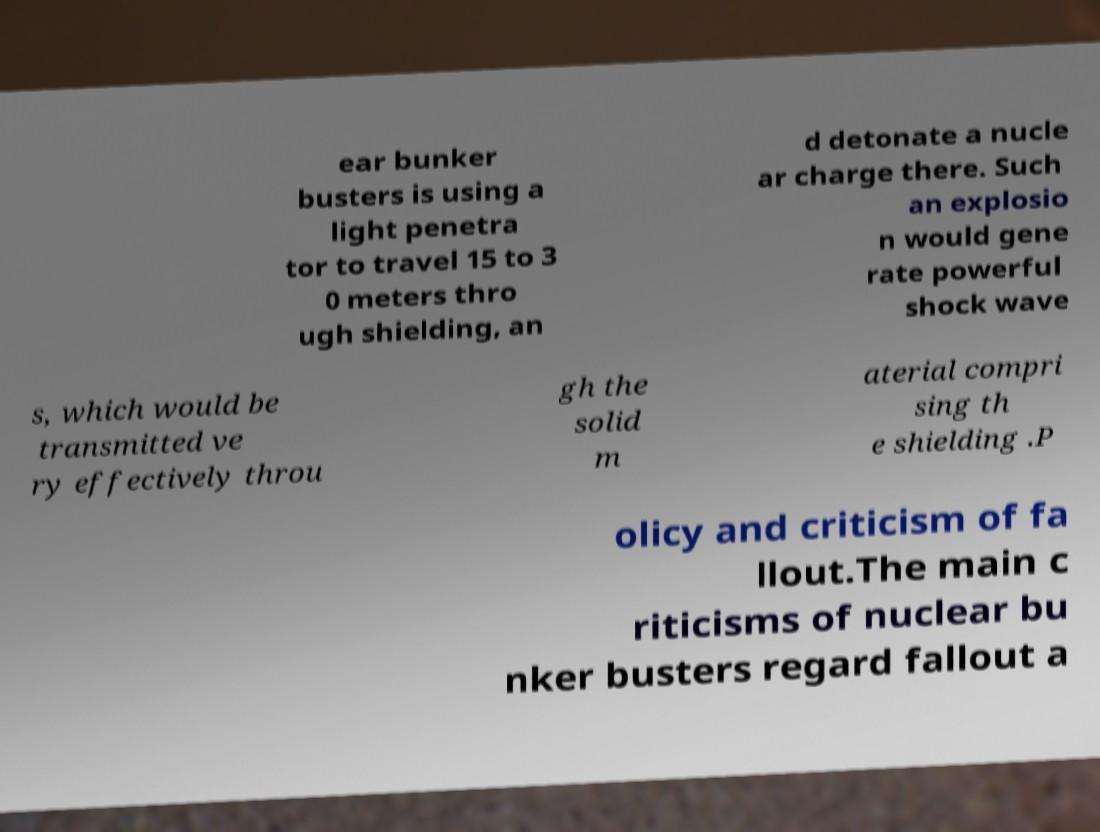Can you accurately transcribe the text from the provided image for me? ear bunker busters is using a light penetra tor to travel 15 to 3 0 meters thro ugh shielding, an d detonate a nucle ar charge there. Such an explosio n would gene rate powerful shock wave s, which would be transmitted ve ry effectively throu gh the solid m aterial compri sing th e shielding .P olicy and criticism of fa llout.The main c riticisms of nuclear bu nker busters regard fallout a 